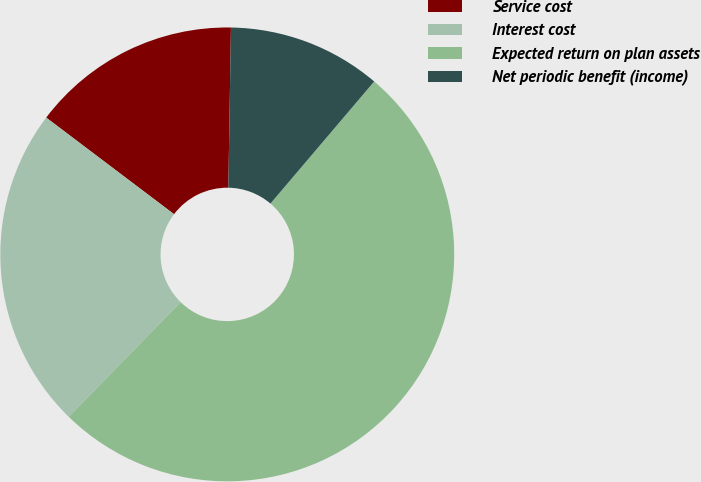Convert chart. <chart><loc_0><loc_0><loc_500><loc_500><pie_chart><fcel>Service cost<fcel>Interest cost<fcel>Expected return on plan assets<fcel>Net periodic benefit (income)<nl><fcel>14.96%<fcel>22.99%<fcel>51.09%<fcel>10.95%<nl></chart> 